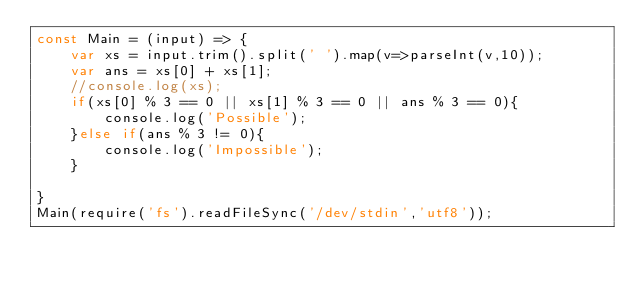Convert code to text. <code><loc_0><loc_0><loc_500><loc_500><_JavaScript_>const Main = (input) => {
	var xs = input.trim().split(' ').map(v=>parseInt(v,10));
    var ans = xs[0] + xs[1];
    //console.log(xs);
    if(xs[0] % 3 == 0 || xs[1] % 3 == 0 || ans % 3 == 0){
    	console.log('Possible');
    }else if(ans % 3 != 0){
    	console.log('Impossible');
    }
    
}
Main(require('fs').readFileSync('/dev/stdin','utf8'));</code> 